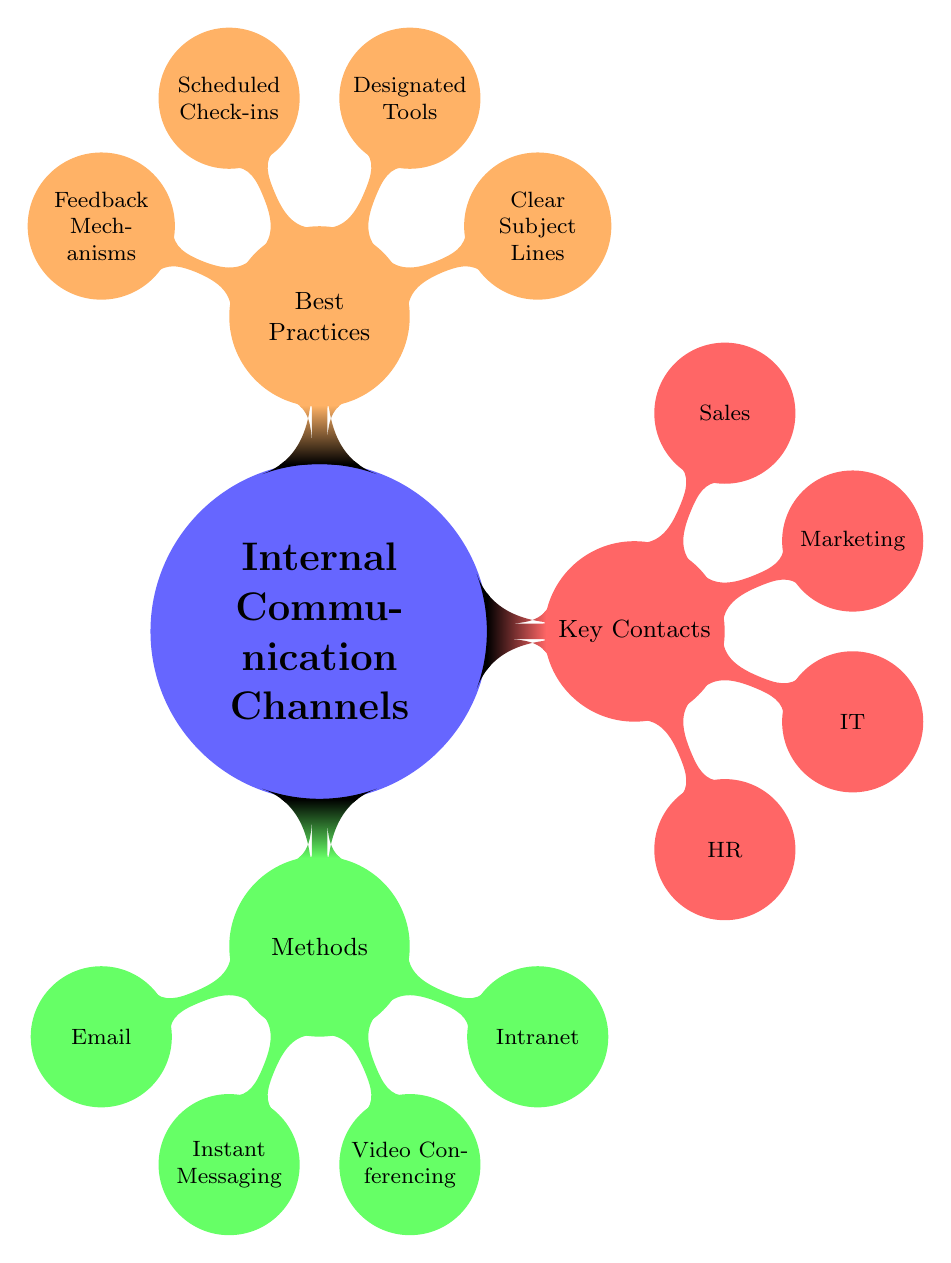What are the methods of internal communication? The methods are listed under the "Methods" node, which includes Email, Instant Messaging, Video Conferencing, and Intranet.
Answer: Email, Instant Messaging, Video Conferencing, Intranet Who is the key contact in the HR Department? The HR Department node specifies Alice Johnson as the key contact.
Answer: Alice Johnson How many key contact nodes are there in total? The "Key Contacts" node branches into four departments: HR, IT, Marketing, and Sales, leading to a total of four key contacts.
Answer: 4 What type of communication platform is used for Instant Messaging? Looking under the "Instant Messaging" node, it specifies the use of Slack and Microsoft Teams.
Answer: Slack, Microsoft Teams Which best practice emphasizes using appropriate tools? The "Designated Communication Tools" is the practice that emphasizes using appropriate tools for different types of communication.
Answer: Designated Tools Who handles contact for the Sales Department? The Sales Department branch identifies David Brown as the contact person.
Answer: David Brown Which method of communication is most suitable for formal communication? The diagram indicates that Email is the method most suitable for formal communication.
Answer: Email What best practice suggests regular interaction between departments? The "Scheduled Check-ins" best practice suggests having regular meetings to maintain consistent communication.
Answer: Scheduled Check-ins What is the description given for Video Conferencing? The description for Video Conferencing under the respective node states that it is for virtual meetings providing real-time face-to-face interaction.
Answer: Virtual meetings for real-time face-to-face interaction 